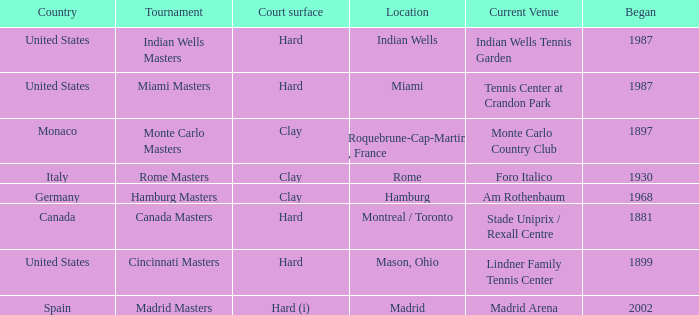How many tournaments have their current venue as the Lindner Family Tennis Center? 1.0. 